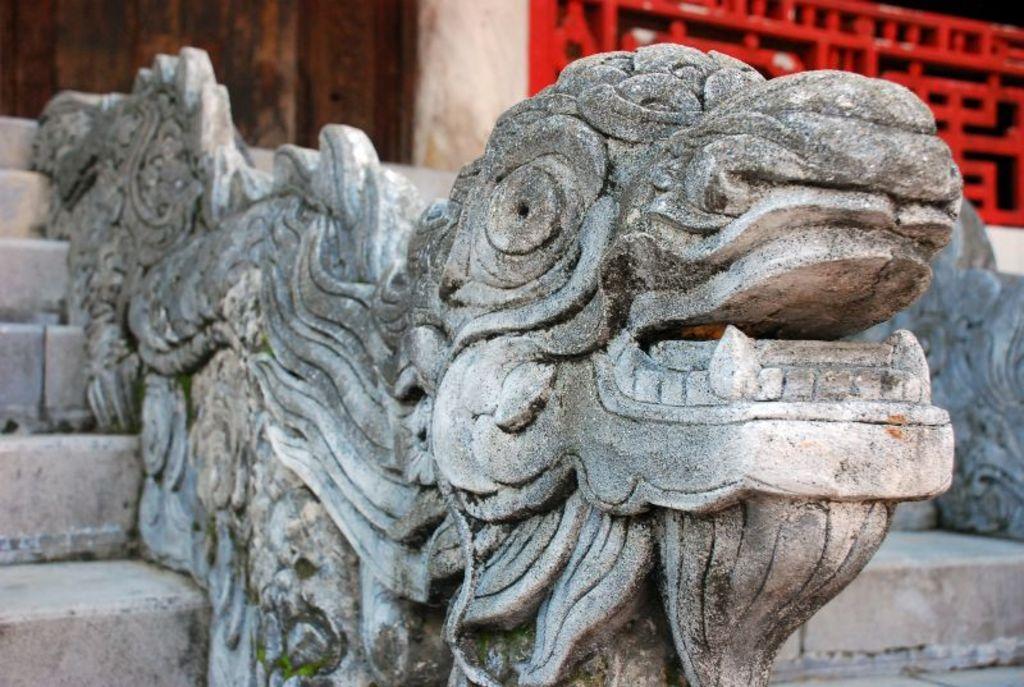Could you give a brief overview of what you see in this image? In this image we can see a sculpture, stairs, red color fencing, and also we can see the wall. 